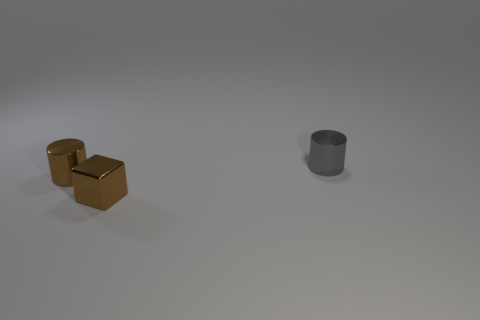What number of other objects are there of the same color as the block?
Keep it short and to the point. 1. There is a metal thing behind the shiny cylinder that is to the left of the cube; how many things are in front of it?
Your answer should be compact. 2. There is a brown shiny object behind the block; is its size the same as the tiny brown metallic cube?
Keep it short and to the point. Yes. Are there fewer gray objects that are right of the gray metallic cylinder than tiny objects in front of the tiny brown shiny block?
Make the answer very short. No. Are there fewer brown cylinders that are behind the gray cylinder than yellow blocks?
Provide a succinct answer. No. There is a tiny cylinder that is the same color as the small metallic block; what material is it?
Your answer should be very brief. Metal. How many tiny green cylinders have the same material as the small gray object?
Give a very brief answer. 0. There is a cube that is the same material as the small gray thing; what is its color?
Provide a succinct answer. Brown. What is the shape of the tiny gray metal thing?
Keep it short and to the point. Cylinder. There is a tiny brown object to the left of the small brown cube; what material is it?
Your response must be concise. Metal. 